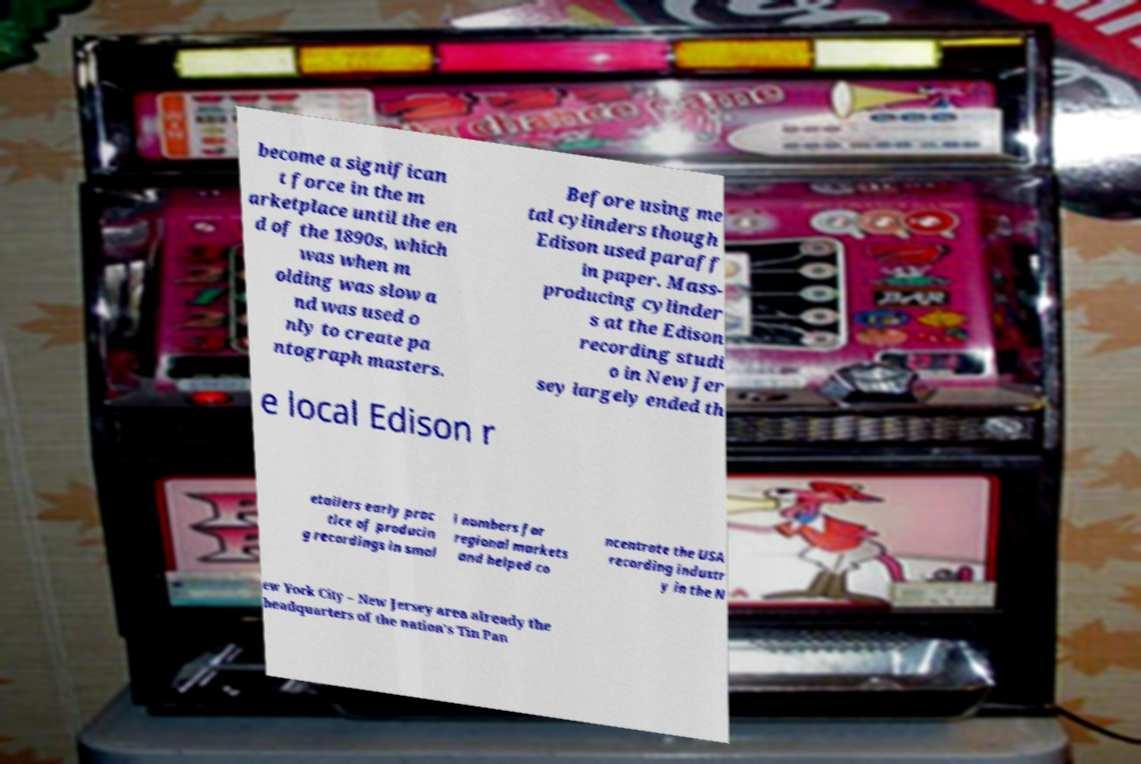What messages or text are displayed in this image? I need them in a readable, typed format. become a significan t force in the m arketplace until the en d of the 1890s, which was when m olding was slow a nd was used o nly to create pa ntograph masters. Before using me tal cylinders though Edison used paraff in paper. Mass- producing cylinder s at the Edison recording studi o in New Jer sey largely ended th e local Edison r etailers early prac tice of producin g recordings in smal l numbers for regional markets and helped co ncentrate the USA recording industr y in the N ew York City – New Jersey area already the headquarters of the nation's Tin Pan 